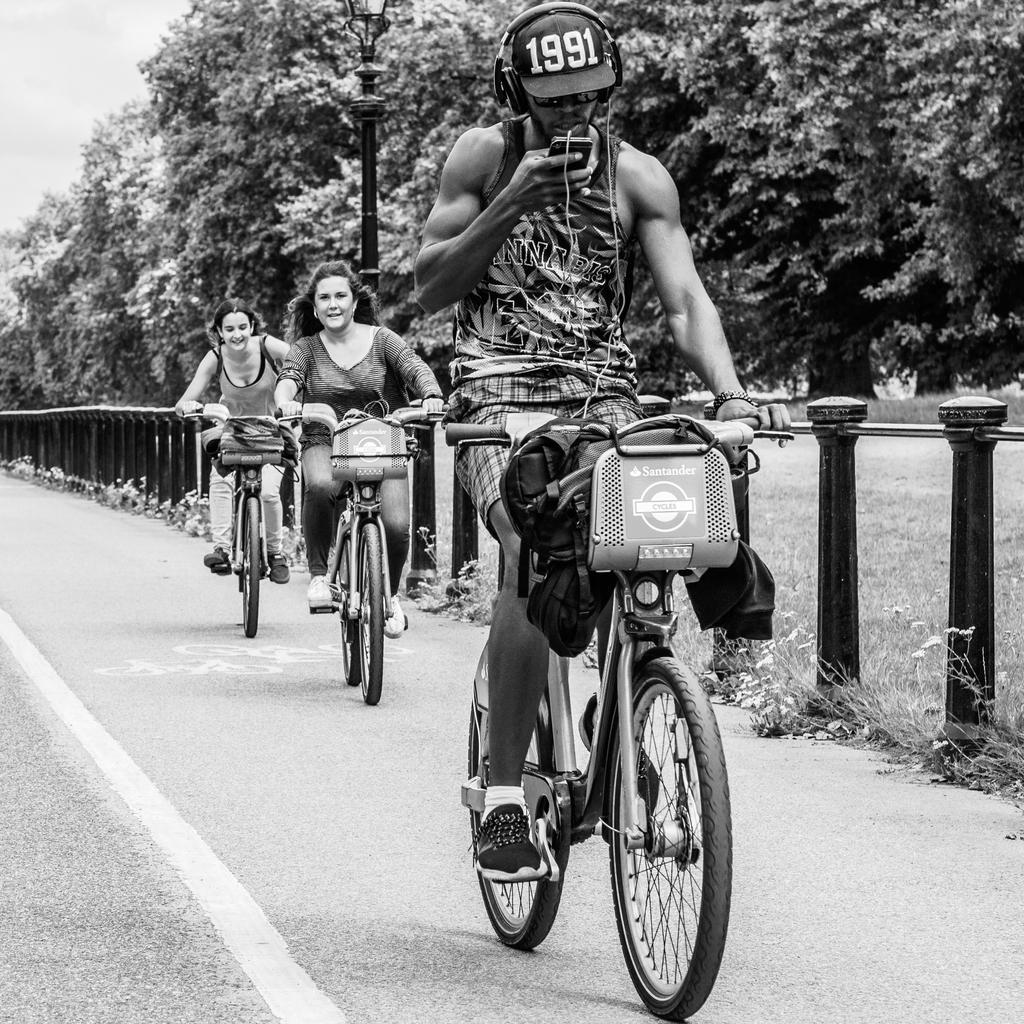Please provide a concise description of this image. As we can see in the image there are trees and three people riding bicycles on road. 